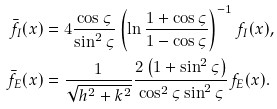<formula> <loc_0><loc_0><loc_500><loc_500>\bar { f } _ { I } ( x ) & = 4 \frac { \cos \varsigma } { \sin ^ { 2 } \varsigma } \left ( \ln \frac { 1 + \cos \varsigma } { 1 - \cos \varsigma } \right ) ^ { - 1 } f _ { I } ( x ) , \\ \bar { f } _ { E } ( x ) & = \frac { 1 } { \sqrt { h ^ { 2 } + k ^ { 2 } } } \frac { 2 \left ( 1 + \sin ^ { 2 } \varsigma \right ) } { \cos ^ { 2 } \varsigma \sin ^ { 2 } \varsigma } f _ { E } ( x ) .</formula> 